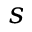<formula> <loc_0><loc_0><loc_500><loc_500>s</formula> 